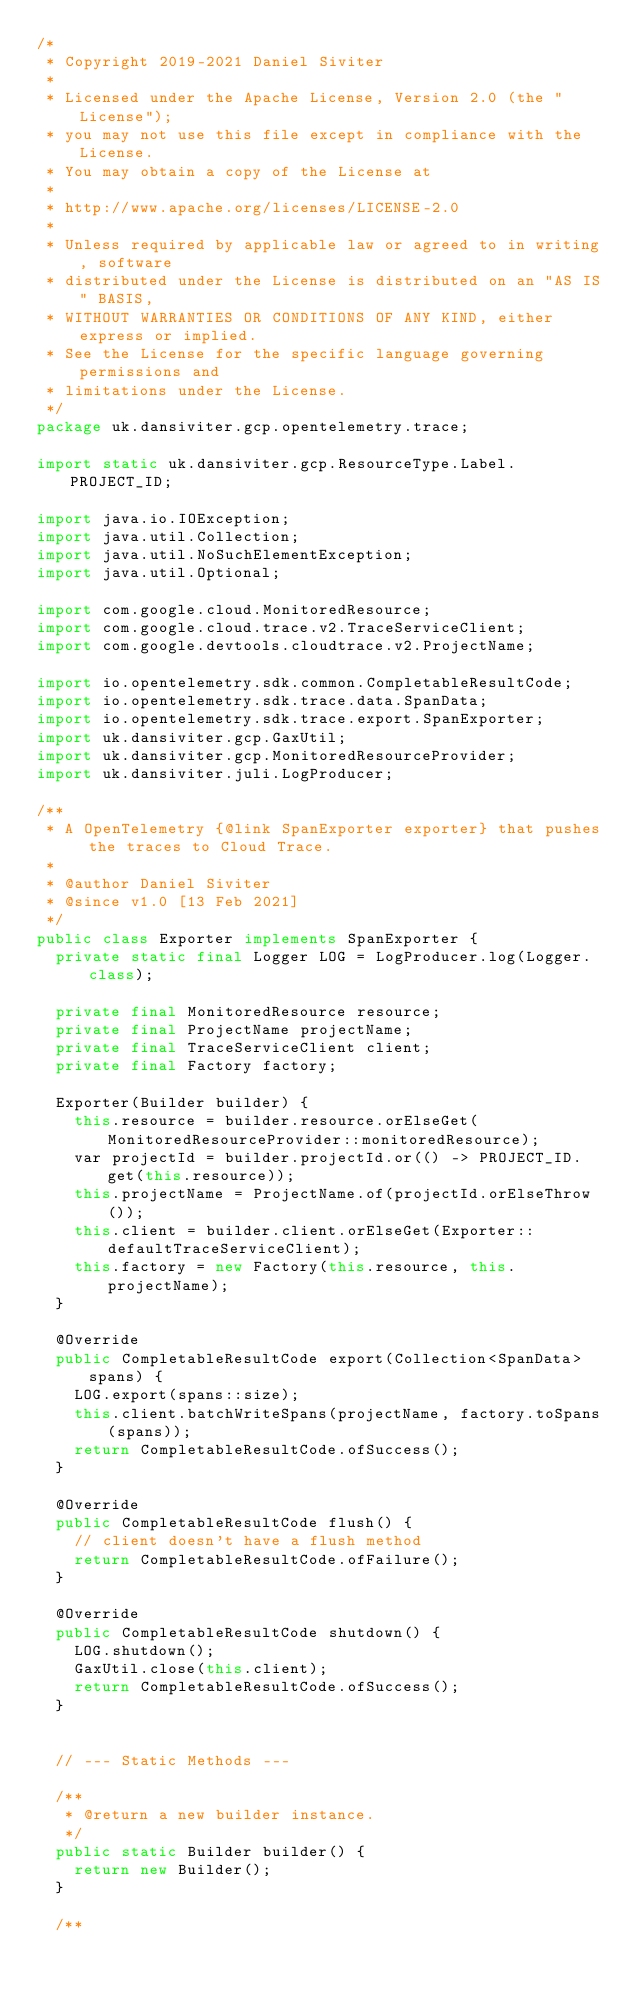<code> <loc_0><loc_0><loc_500><loc_500><_Java_>/*
 * Copyright 2019-2021 Daniel Siviter
 *
 * Licensed under the Apache License, Version 2.0 (the "License");
 * you may not use this file except in compliance with the License.
 * You may obtain a copy of the License at
 *
 * http://www.apache.org/licenses/LICENSE-2.0
 *
 * Unless required by applicable law or agreed to in writing, software
 * distributed under the License is distributed on an "AS IS" BASIS,
 * WITHOUT WARRANTIES OR CONDITIONS OF ANY KIND, either express or implied.
 * See the License for the specific language governing permissions and
 * limitations under the License.
 */
package uk.dansiviter.gcp.opentelemetry.trace;

import static uk.dansiviter.gcp.ResourceType.Label.PROJECT_ID;

import java.io.IOException;
import java.util.Collection;
import java.util.NoSuchElementException;
import java.util.Optional;

import com.google.cloud.MonitoredResource;
import com.google.cloud.trace.v2.TraceServiceClient;
import com.google.devtools.cloudtrace.v2.ProjectName;

import io.opentelemetry.sdk.common.CompletableResultCode;
import io.opentelemetry.sdk.trace.data.SpanData;
import io.opentelemetry.sdk.trace.export.SpanExporter;
import uk.dansiviter.gcp.GaxUtil;
import uk.dansiviter.gcp.MonitoredResourceProvider;
import uk.dansiviter.juli.LogProducer;

/**
 * A OpenTelemetry {@link SpanExporter exporter} that pushes the traces to Cloud Trace.
 *
 * @author Daniel Siviter
 * @since v1.0 [13 Feb 2021]
 */
public class Exporter implements SpanExporter {
	private static final Logger LOG = LogProducer.log(Logger.class);

	private final MonitoredResource resource;
	private final ProjectName projectName;
	private final TraceServiceClient client;
	private final Factory factory;

	Exporter(Builder builder) {
		this.resource = builder.resource.orElseGet(MonitoredResourceProvider::monitoredResource);
		var projectId = builder.projectId.or(() -> PROJECT_ID.get(this.resource));
		this.projectName = ProjectName.of(projectId.orElseThrow());
		this.client = builder.client.orElseGet(Exporter::defaultTraceServiceClient);
		this.factory = new Factory(this.resource, this.projectName);
	}

	@Override
	public CompletableResultCode export(Collection<SpanData> spans) {
		LOG.export(spans::size);
		this.client.batchWriteSpans(projectName, factory.toSpans(spans));
		return CompletableResultCode.ofSuccess();
	}

	@Override
	public CompletableResultCode flush() {
		// client doesn't have a flush method
		return CompletableResultCode.ofFailure();
	}

	@Override
	public CompletableResultCode shutdown() {
		LOG.shutdown();
		GaxUtil.close(this.client);
		return CompletableResultCode.ofSuccess();
	}


	// --- Static Methods ---

	/**
	 * @return a new builder instance.
	 */
	public static Builder builder() {
		return new Builder();
	}

	/**</code> 